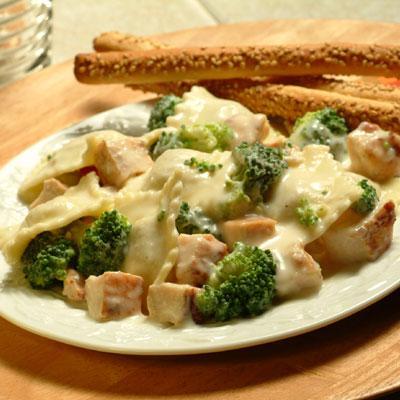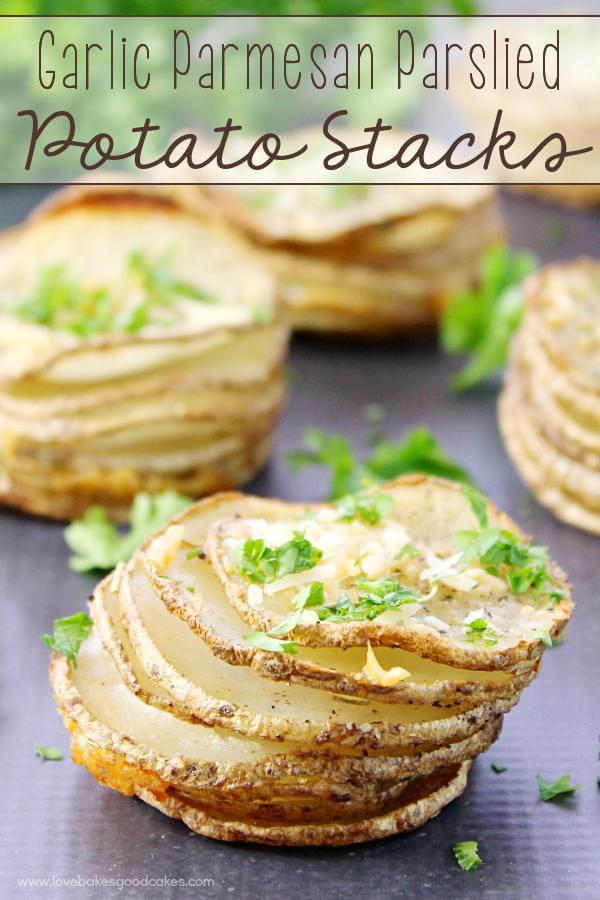The first image is the image on the left, the second image is the image on the right. For the images displayed, is the sentence "One image shows stacked disk shapes garnished with green sprigs, and the other image features something creamy with broccoli florets in it." factually correct? Answer yes or no. Yes. 